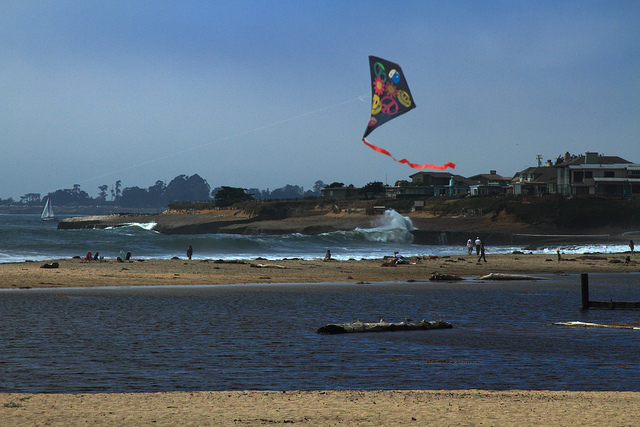<image>How many trees are under the blue sky? I don't know how many trees are under the blue sky. It could be any number ranging from 0 to several. How many trees are under the blue sky? It is unanswerable how many trees are under the blue sky. 